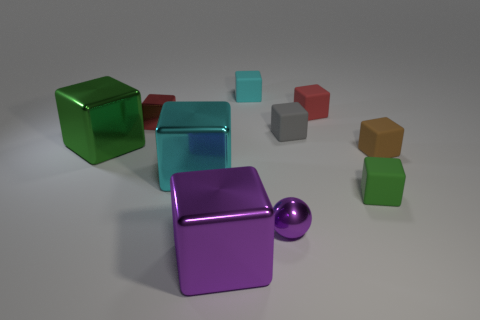What material is the cube that is both right of the small red metal cube and on the left side of the large purple thing? The cube located to the right of the small red metal cube and on the left side of the large purple object appears to be made of metal as well. It reflects light in a way that is characteristic of polished metal surfaces, indicating it likely shares the same material properties as the red cube. 